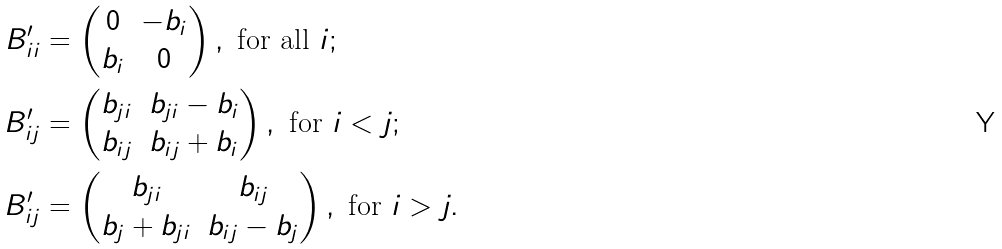Convert formula to latex. <formula><loc_0><loc_0><loc_500><loc_500>B ^ { \prime } _ { i i } & = \begin{pmatrix} 0 & - b _ { i } \\ b _ { i } & 0 \end{pmatrix} , \text { for all } i ; \\ B ^ { \prime } _ { i j } & = \begin{pmatrix} b _ { j i } & b _ { j i } - b _ { i } \\ b _ { i j } & b _ { i j } + b _ { i } \end{pmatrix} , \text { for } i < j ; \\ B ^ { \prime } _ { i j } & = \begin{pmatrix} b _ { j i } & b _ { i j } \\ b _ { j } + b _ { j i } & b _ { i j } - b _ { j } \end{pmatrix} , \text { for } i > j .</formula> 